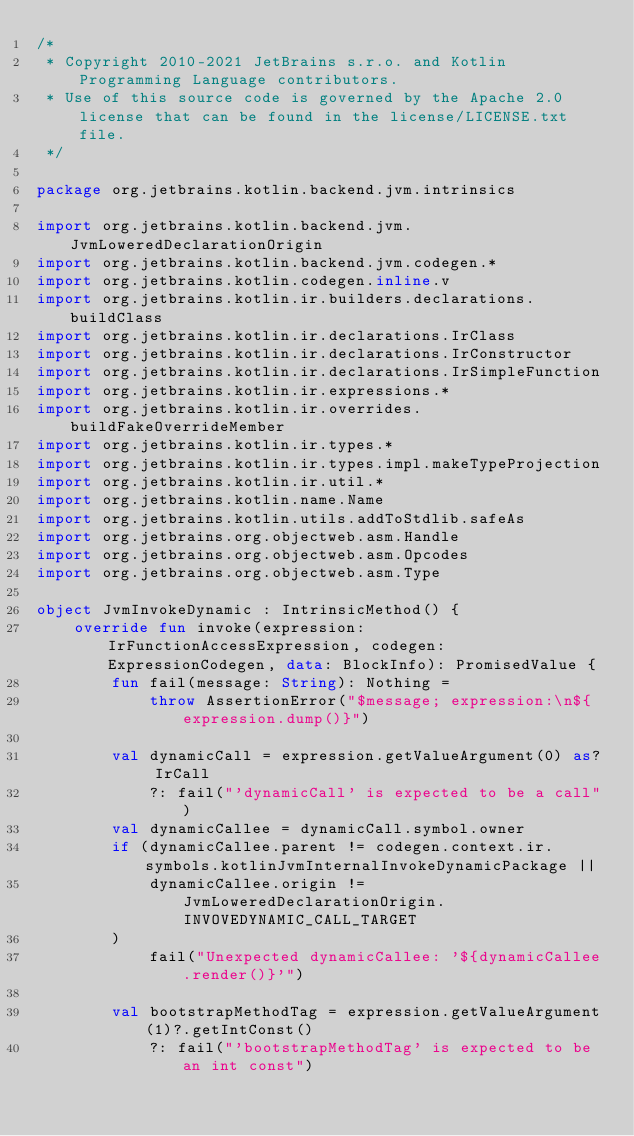<code> <loc_0><loc_0><loc_500><loc_500><_Kotlin_>/*
 * Copyright 2010-2021 JetBrains s.r.o. and Kotlin Programming Language contributors.
 * Use of this source code is governed by the Apache 2.0 license that can be found in the license/LICENSE.txt file.
 */

package org.jetbrains.kotlin.backend.jvm.intrinsics

import org.jetbrains.kotlin.backend.jvm.JvmLoweredDeclarationOrigin
import org.jetbrains.kotlin.backend.jvm.codegen.*
import org.jetbrains.kotlin.codegen.inline.v
import org.jetbrains.kotlin.ir.builders.declarations.buildClass
import org.jetbrains.kotlin.ir.declarations.IrClass
import org.jetbrains.kotlin.ir.declarations.IrConstructor
import org.jetbrains.kotlin.ir.declarations.IrSimpleFunction
import org.jetbrains.kotlin.ir.expressions.*
import org.jetbrains.kotlin.ir.overrides.buildFakeOverrideMember
import org.jetbrains.kotlin.ir.types.*
import org.jetbrains.kotlin.ir.types.impl.makeTypeProjection
import org.jetbrains.kotlin.ir.util.*
import org.jetbrains.kotlin.name.Name
import org.jetbrains.kotlin.utils.addToStdlib.safeAs
import org.jetbrains.org.objectweb.asm.Handle
import org.jetbrains.org.objectweb.asm.Opcodes
import org.jetbrains.org.objectweb.asm.Type

object JvmInvokeDynamic : IntrinsicMethod() {
    override fun invoke(expression: IrFunctionAccessExpression, codegen: ExpressionCodegen, data: BlockInfo): PromisedValue {
        fun fail(message: String): Nothing =
            throw AssertionError("$message; expression:\n${expression.dump()}")

        val dynamicCall = expression.getValueArgument(0) as? IrCall
            ?: fail("'dynamicCall' is expected to be a call")
        val dynamicCallee = dynamicCall.symbol.owner
        if (dynamicCallee.parent != codegen.context.ir.symbols.kotlinJvmInternalInvokeDynamicPackage ||
            dynamicCallee.origin != JvmLoweredDeclarationOrigin.INVOVEDYNAMIC_CALL_TARGET
        )
            fail("Unexpected dynamicCallee: '${dynamicCallee.render()}'")

        val bootstrapMethodTag = expression.getValueArgument(1)?.getIntConst()
            ?: fail("'bootstrapMethodTag' is expected to be an int const")</code> 